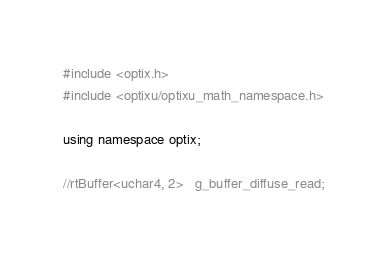Convert code to text. <code><loc_0><loc_0><loc_500><loc_500><_Cuda_>#include <optix.h>
#include <optixu/optixu_math_namespace.h>

using namespace optix;

//rtBuffer<uchar4, 2>   g_buffer_diffuse_read;</code> 